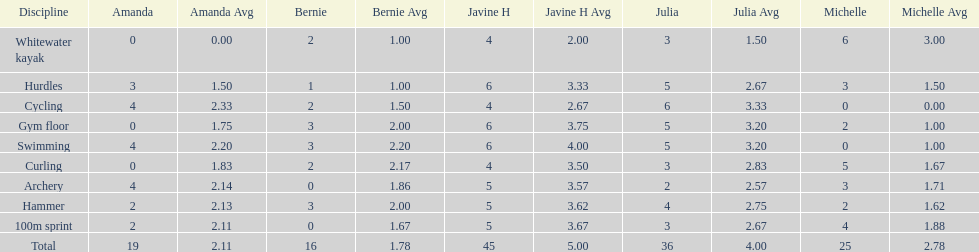What is the first discipline listed on this chart? Whitewater kayak. 